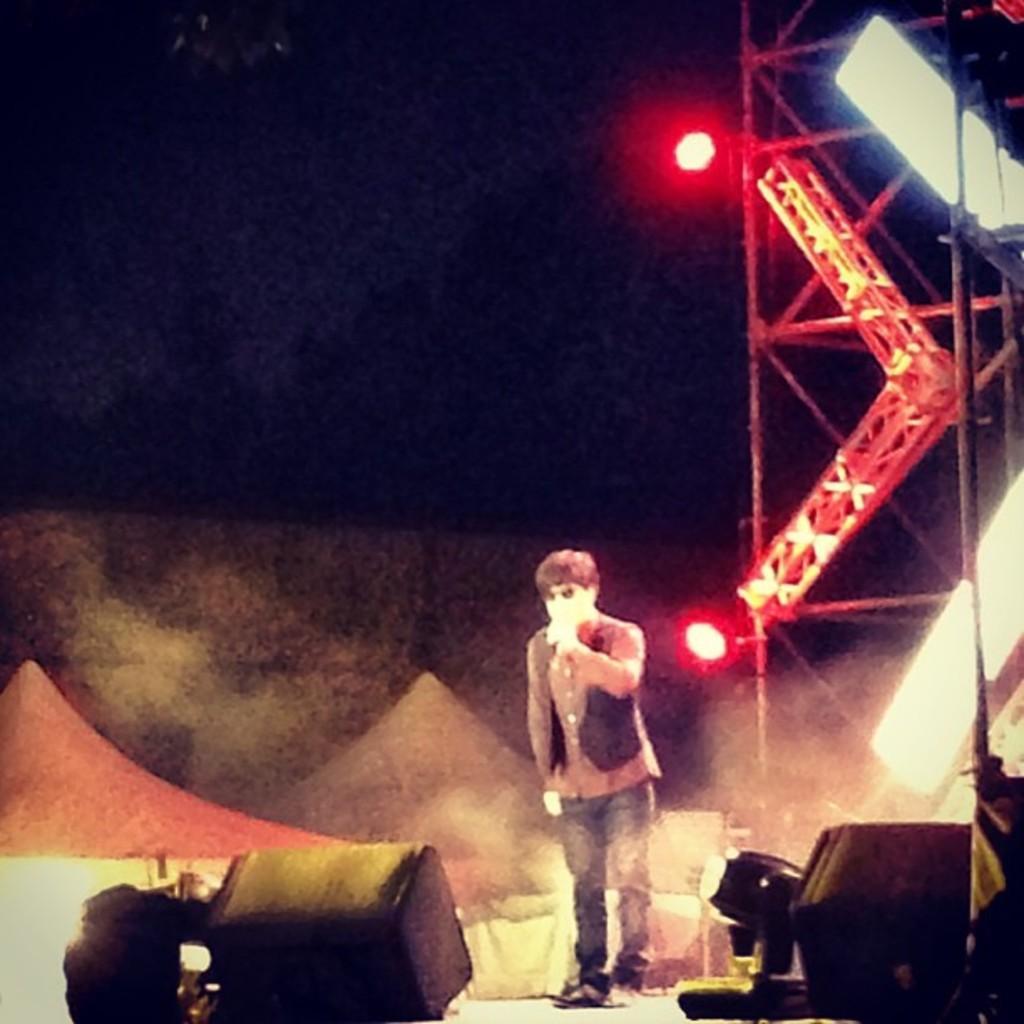How would you summarize this image in a sentence or two? In this image I can see a man is standing. On the right side, I can see the lights and rods. 